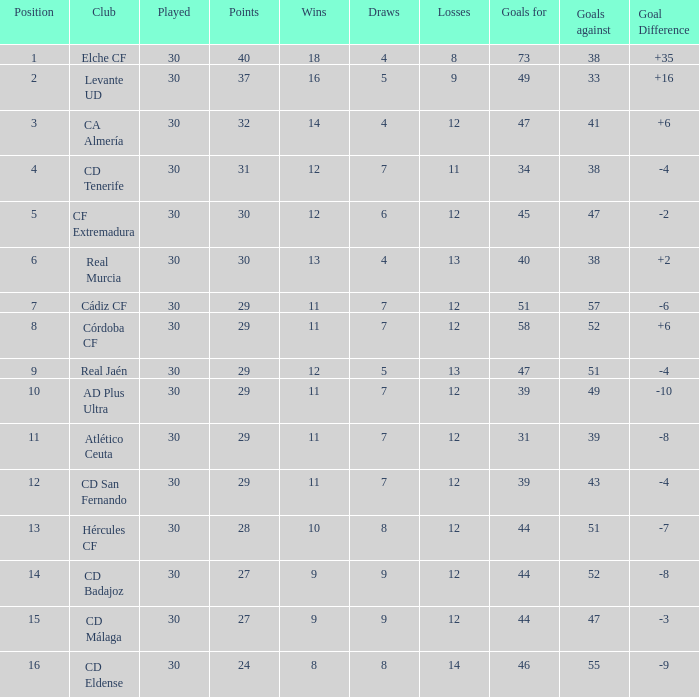What is the total of goals that have fewer than 30 points, a rank lower than 10, and over 57 goals conceded? None. 